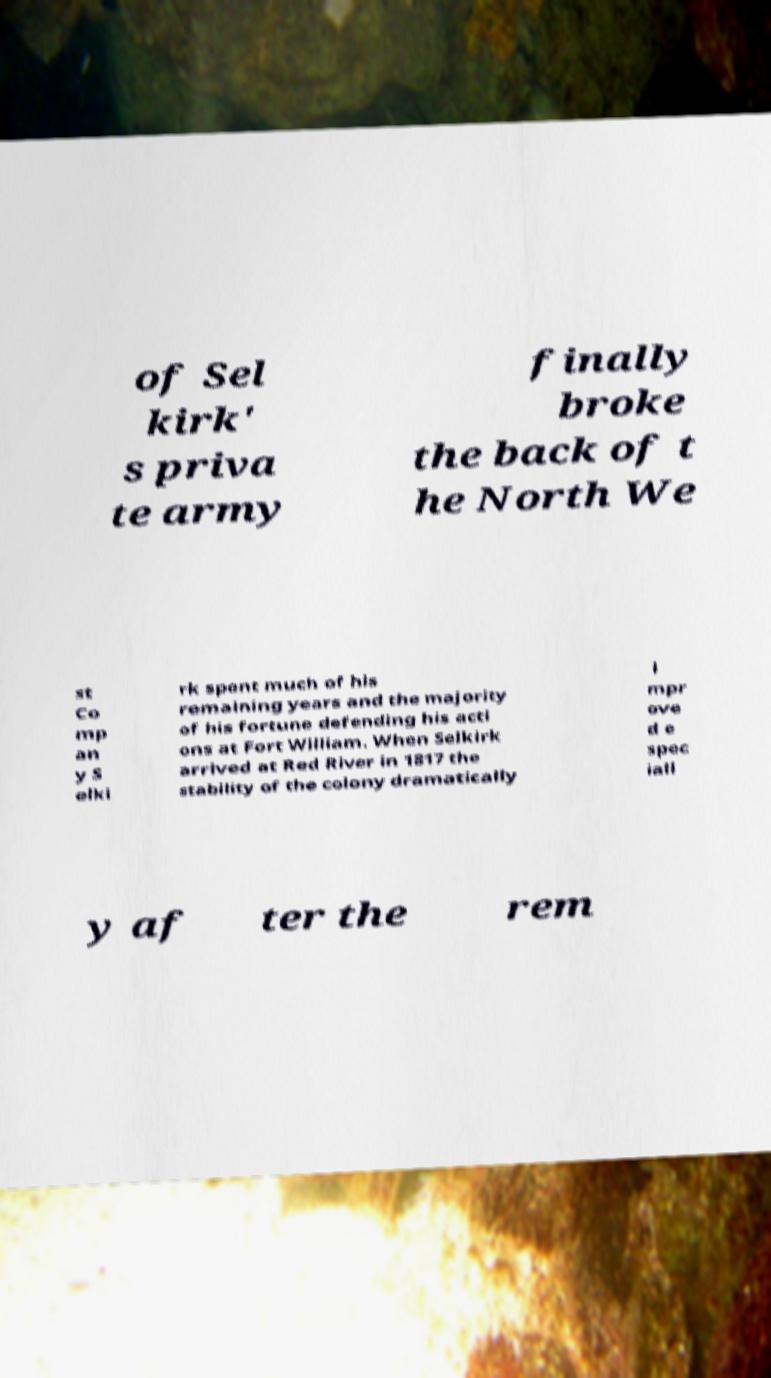For documentation purposes, I need the text within this image transcribed. Could you provide that? of Sel kirk' s priva te army finally broke the back of t he North We st Co mp an y S elki rk spent much of his remaining years and the majority of his fortune defending his acti ons at Fort William. When Selkirk arrived at Red River in 1817 the stability of the colony dramatically i mpr ove d e spec iall y af ter the rem 